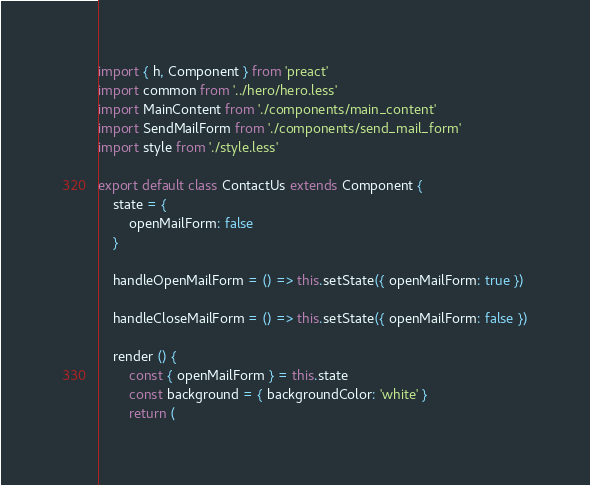<code> <loc_0><loc_0><loc_500><loc_500><_JavaScript_>import { h, Component } from 'preact'
import common from '../hero/hero.less'
import MainContent from './components/main_content'
import SendMailForm from './components/send_mail_form'
import style from './style.less'

export default class ContactUs extends Component {
	state = {
		openMailForm: false
	}

	handleOpenMailForm = () => this.setState({ openMailForm: true })

	handleCloseMailForm = () => this.setState({ openMailForm: false })

	render () {
		const { openMailForm } = this.state
		const background = { backgroundColor: 'white' }
		return (</code> 